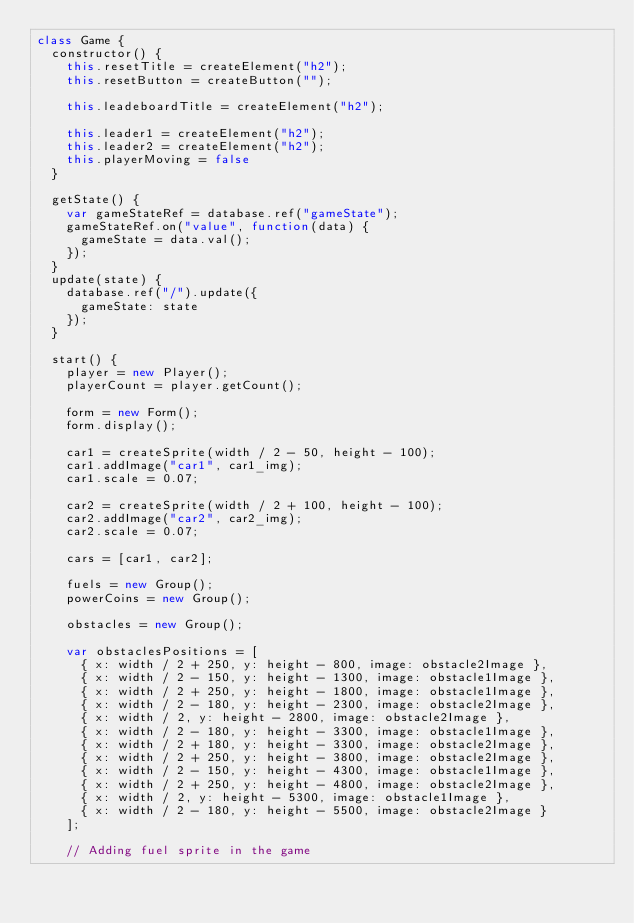<code> <loc_0><loc_0><loc_500><loc_500><_JavaScript_>class Game {
  constructor() {
    this.resetTitle = createElement("h2");
    this.resetButton = createButton("");

    this.leadeboardTitle = createElement("h2");

    this.leader1 = createElement("h2");
    this.leader2 = createElement("h2");
    this.playerMoving = false
  }

  getState() {
    var gameStateRef = database.ref("gameState");
    gameStateRef.on("value", function(data) {
      gameState = data.val();
    });
  }
  update(state) {
    database.ref("/").update({
      gameState: state
    });
  }

  start() {
    player = new Player();
    playerCount = player.getCount();

    form = new Form();
    form.display();

    car1 = createSprite(width / 2 - 50, height - 100);
    car1.addImage("car1", car1_img);
    car1.scale = 0.07;

    car2 = createSprite(width / 2 + 100, height - 100);
    car2.addImage("car2", car2_img);
    car2.scale = 0.07;

    cars = [car1, car2];

    fuels = new Group();
    powerCoins = new Group();

    obstacles = new Group();

    var obstaclesPositions = [
      { x: width / 2 + 250, y: height - 800, image: obstacle2Image },
      { x: width / 2 - 150, y: height - 1300, image: obstacle1Image },
      { x: width / 2 + 250, y: height - 1800, image: obstacle1Image },
      { x: width / 2 - 180, y: height - 2300, image: obstacle2Image },
      { x: width / 2, y: height - 2800, image: obstacle2Image },
      { x: width / 2 - 180, y: height - 3300, image: obstacle1Image },
      { x: width / 2 + 180, y: height - 3300, image: obstacle2Image },
      { x: width / 2 + 250, y: height - 3800, image: obstacle2Image },
      { x: width / 2 - 150, y: height - 4300, image: obstacle1Image },
      { x: width / 2 + 250, y: height - 4800, image: obstacle2Image },
      { x: width / 2, y: height - 5300, image: obstacle1Image },
      { x: width / 2 - 180, y: height - 5500, image: obstacle2Image }
    ];

    // Adding fuel sprite in the game</code> 